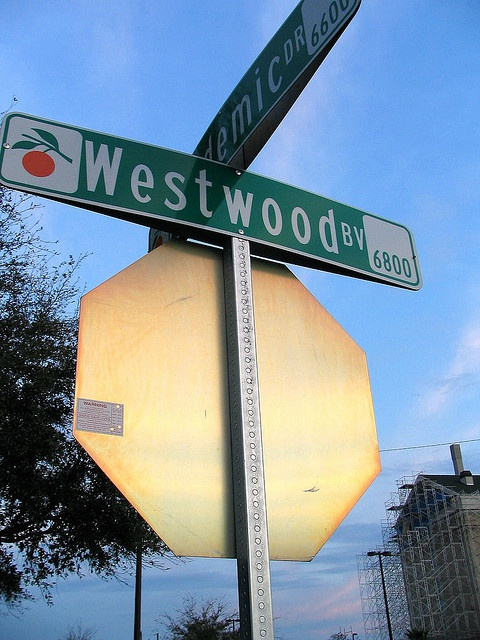Describe the objects in this image and their specific colors. I can see a stop sign in lightblue, khaki, beige, and tan tones in this image. 